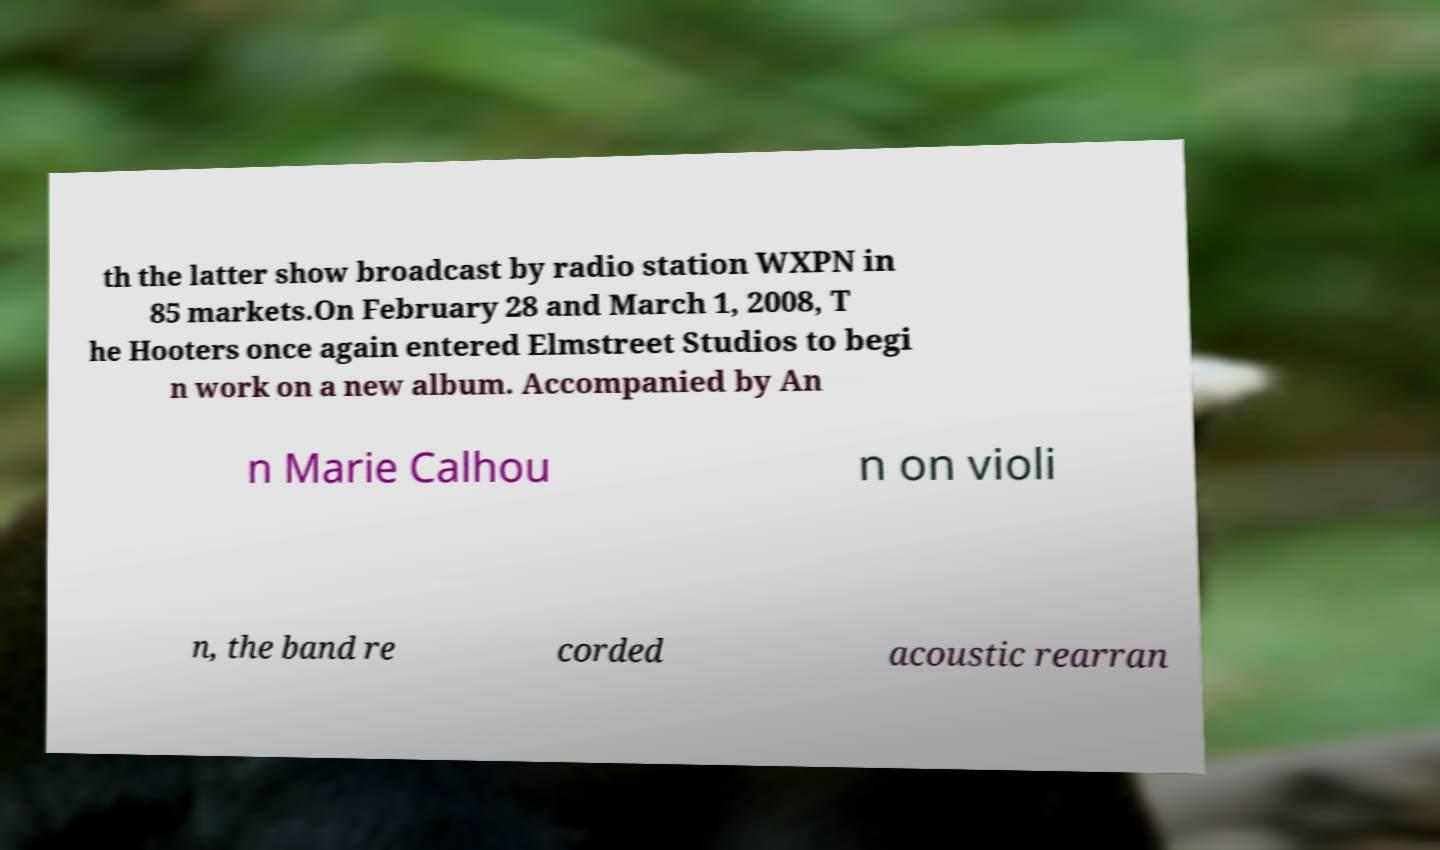Please identify and transcribe the text found in this image. th the latter show broadcast by radio station WXPN in 85 markets.On February 28 and March 1, 2008, T he Hooters once again entered Elmstreet Studios to begi n work on a new album. Accompanied by An n Marie Calhou n on violi n, the band re corded acoustic rearran 